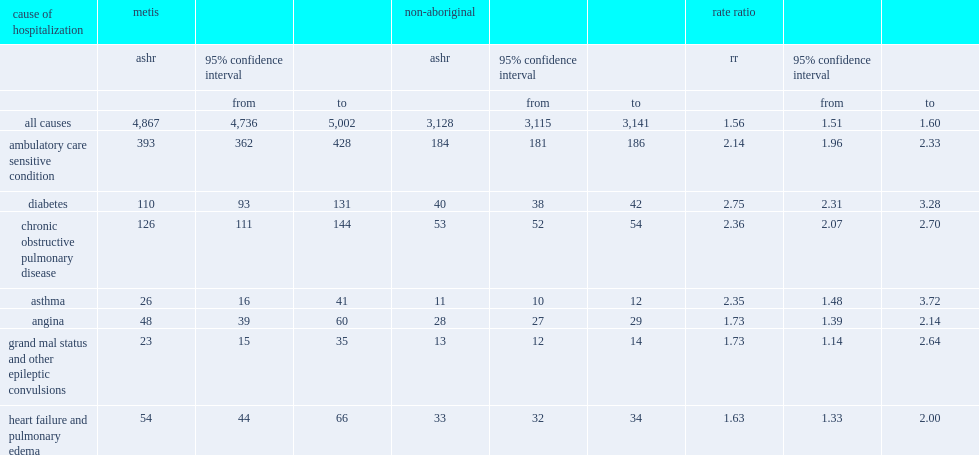How many times were the acsc-related ashr among metis more than that of non-aboriginal people? 2.13587. How many times were diabetes-related hospitalizations among metis higher than that of non-aboriginal people? 2.75. 